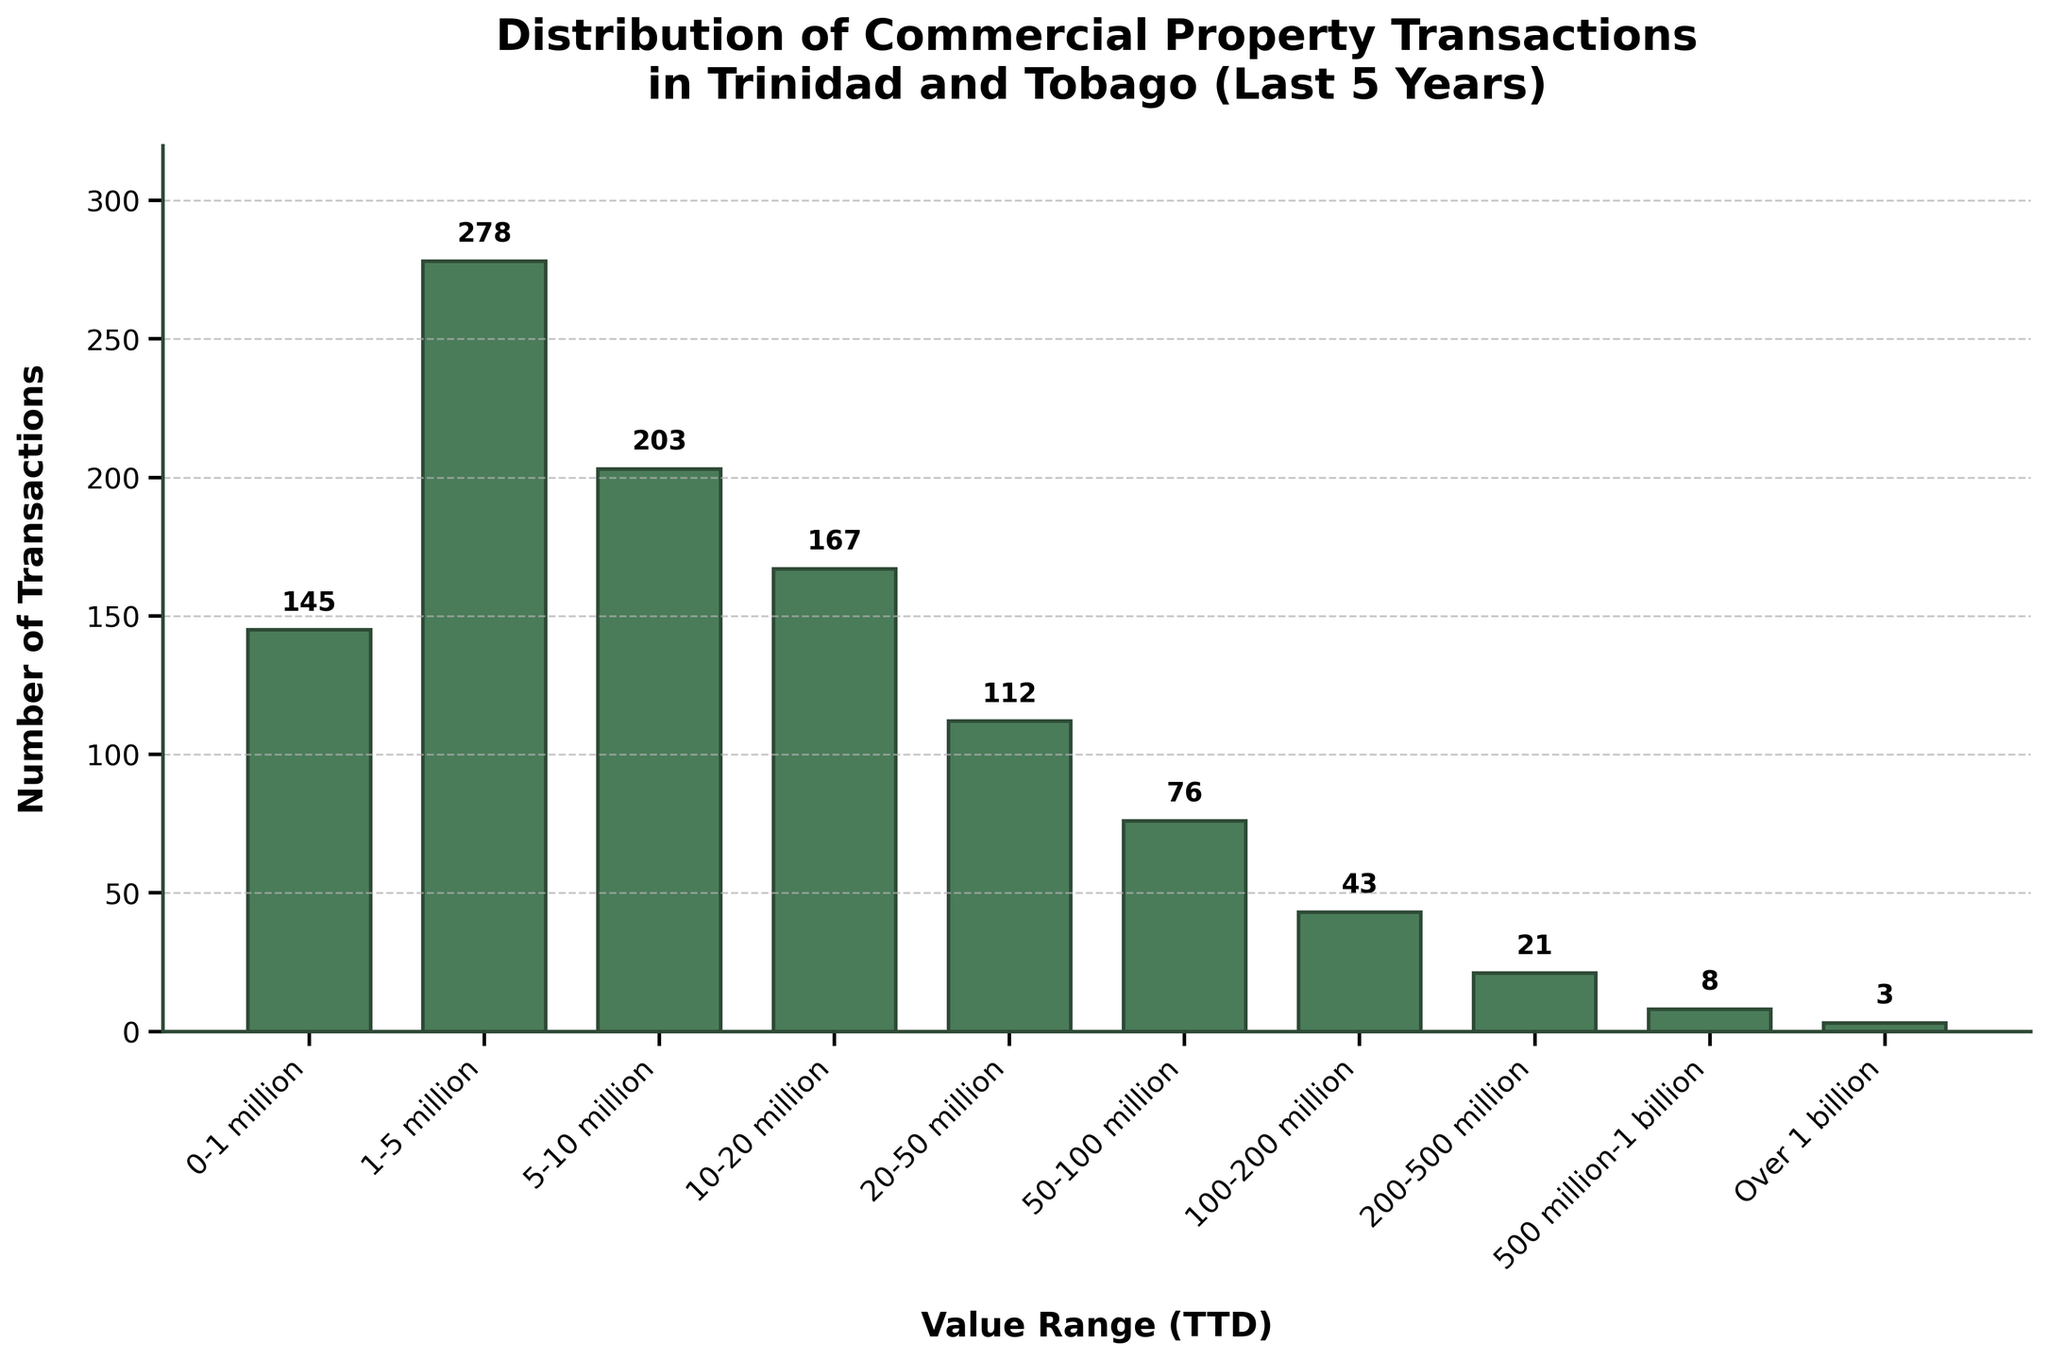Which value range has the highest number of transactions? By observing the height of the bars, the highest one corresponds to the value range of 1-5 million.
Answer: 1-5 million How many transactions are there in total for properties valued between 0 and 20 million? Sum the number of transactions for the ranges 0-1 million (145), 1-5 million (278), 5-10 million (203), and 10-20 million (167). Total = 145 + 278 + 203 + 167 = 793.
Answer: 793 Which value range has the fewest transactions, and how many does it have? By looking at the shortest bar, the "Over 1 billion" range has the fewest transactions, with just 3.
Answer: Over 1 billion, 3 What is the combined number of transactions for the value ranges above 100 million? Sum the number of transactions for the ranges 100-200 million (43), 200-500 million (21), 500 million-1 billion (8), and Over 1 billion (3). Total = 43 + 21 + 8 + 3 = 75.
Answer: 75 How does the number of transactions in the 50-100 million range compare to those in the 20-50 million range? Compare the heights of the bars for these two ranges. The 20-50 million range has 112 transactions, and the 50-100 million range has 76 transactions. 112 > 76.
Answer: 20-50 million has more transactions What is the median number of transactions across all value ranges? Sort the transaction counts (3, 8, 21, 43, 76, 112, 145, 167, 203, 278) and find the middle values (76 and 112), then calculate the average of these two: (76 + 112) / 2 = 94.
Answer: 94 Are there more transactions for properties valued between 10-50 million or for those valued between 50-200 million? Sum the transactions for each range. For 10-50 million: 10-20 million (167) + 20-50 million (112) = 279. For 50-200 million: 50-100 million (76) + 100-200 million (43) = 119. 279 > 119.
Answer: 10-50 million has more transactions Which value range has approximately twice as many transactions as the 50-100 million range? The 50-100 million range has 76 transactions. Approximately twice that number is 76 * 2 = 152. The 0-1 million range with 145 transactions is the closest.
Answer: 0-1 million 